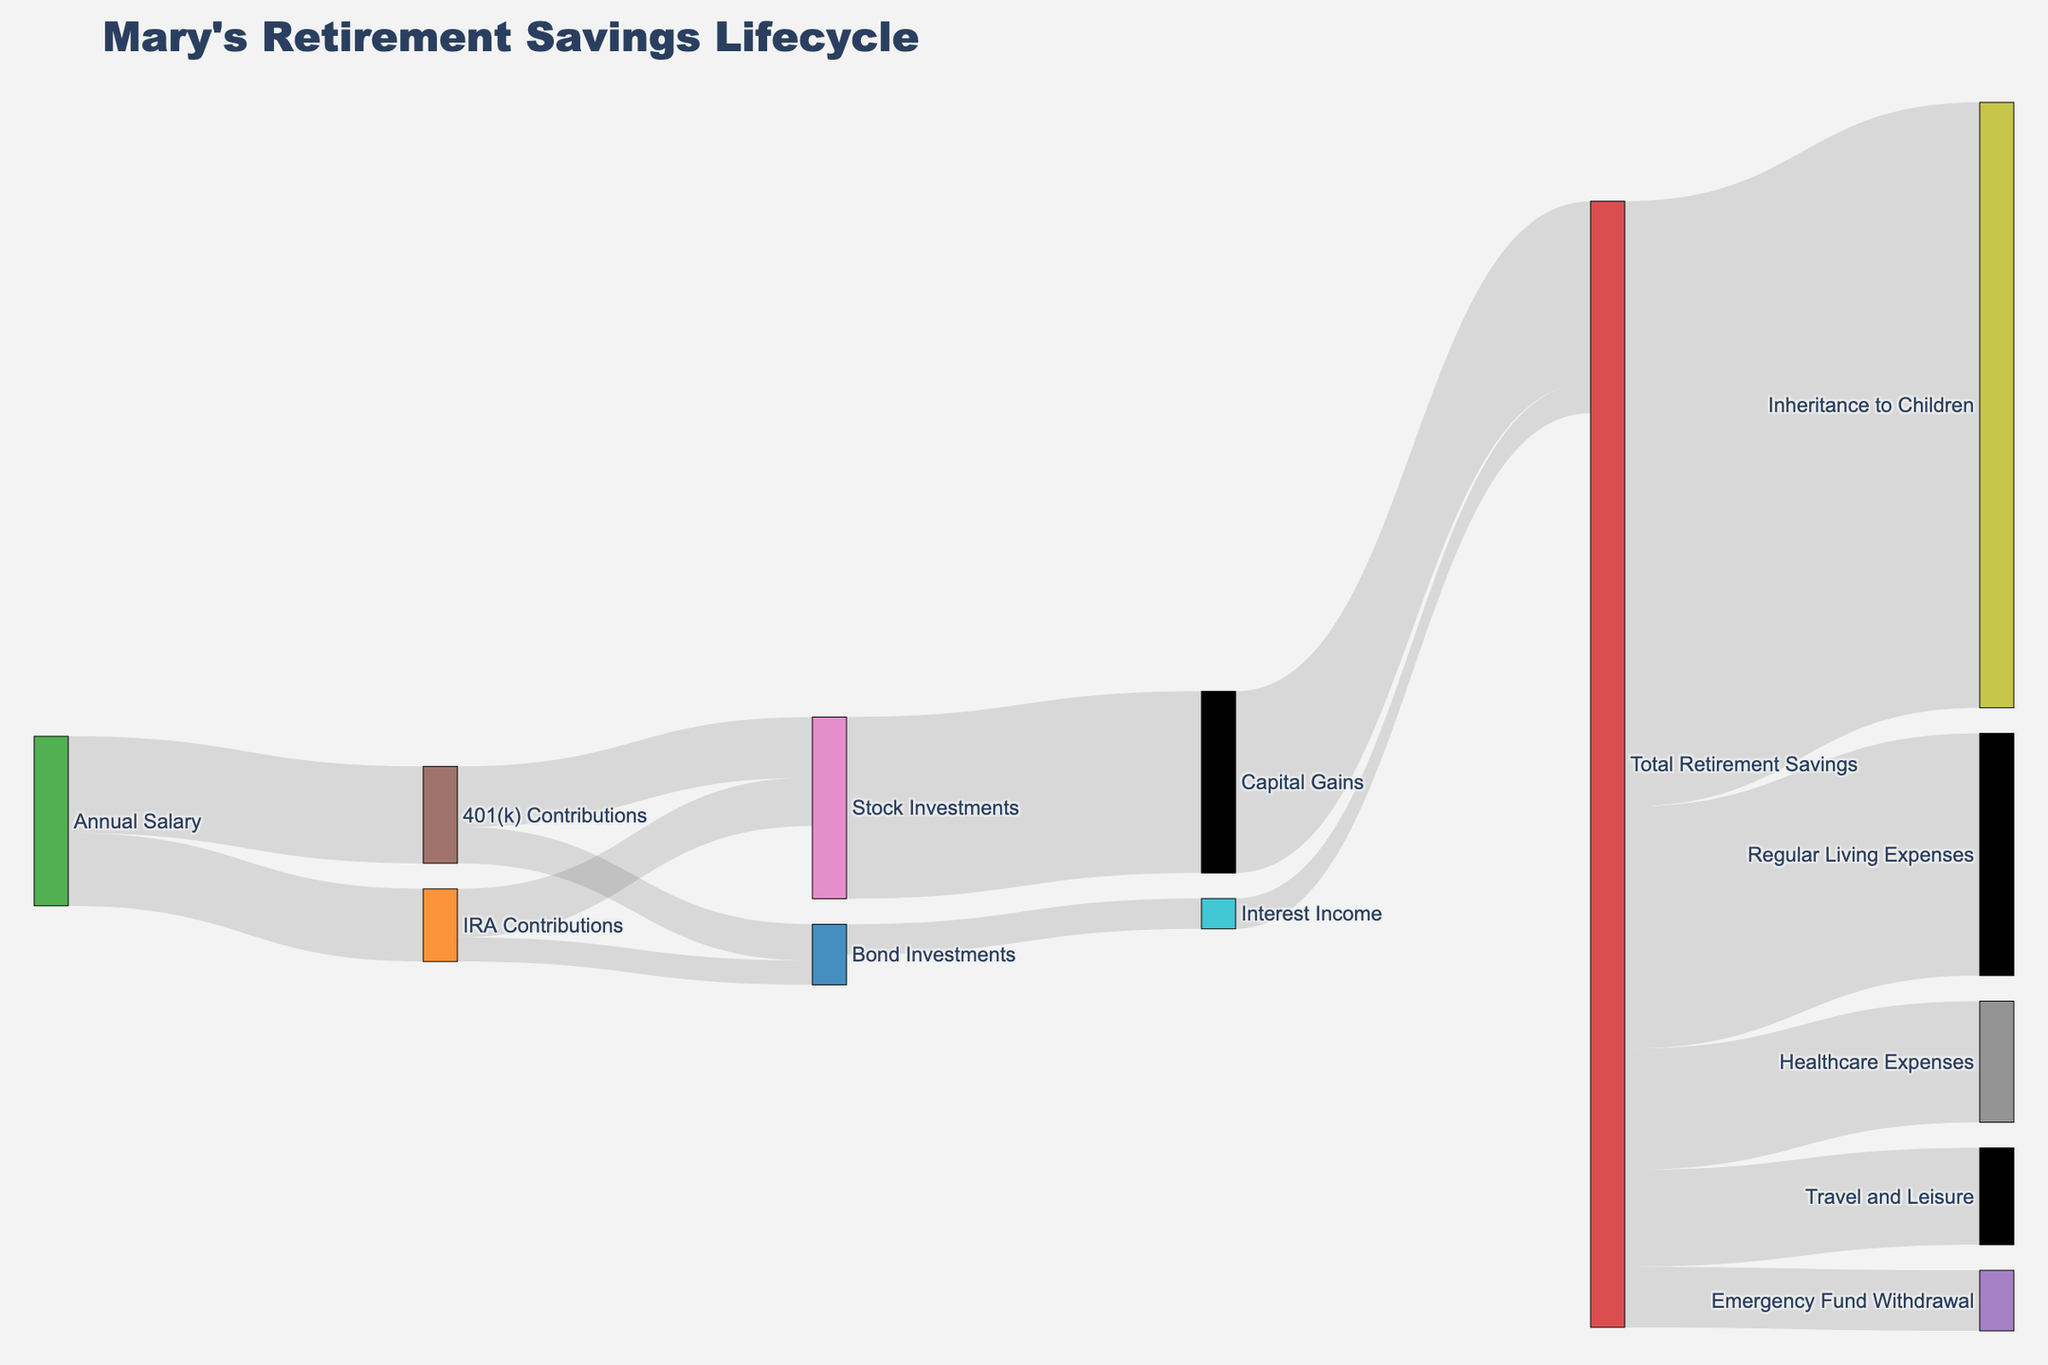What is the largest contribution to Mary's Retirement Savings Lifecycle? The diagram shows contributions from multiple sources. By observing the highest link value contributing to "Total Retirement Savings", we see "Capital Gains" with a value of $15,000.
Answer: Capital Gains How much total did Mary's annual salary contribute to her retirement? Sum the contributions from "Annual Salary" to all its targets, which are $8,000 to 401(k) Contributions and $6,000 to IRA Contributions. Total is $8,000 + $6,000 = $14,000.
Answer: $14,000 What is the total amount withdrawn from Mary's retirement savings? Sum the values of all links that target withdrawals such as "Emergency Fund Withdrawal", "Healthcare Expenses", "Regular Living Expenses", "Travel and Leisure", and "Inheritance to Children". That results in $5,000 + $10,000 + $20,000 + $8,000 + $50,000 = $93,000.
Answer: $93,000 Which has the higher value, Mary's investment in bonds through 401(k) or IRA Contributions? Compare values for "401(k) Contributions" to "Bond Investments" ($3,000) and "IRA Contributions" to "Bond Investments" ($2,000).
Answer: 401(k) Contributions to Bond Investments How much total is invested in stock from both 401(k) and IRA Contributions? Sum the contributions to "Stock Investments" from both "401(k) Contributions" ($5,000) and "IRA Contributions" ($4,000). Total is $5,000 + $4,000 = $9,000.
Answer: $9,000 Which withdrawal category receives more funds, Healthcare Expenses or Travel and Leisure? Compare values: "Healthcare Expenses" receives $10,000 and "Travel and Leisure" gets $8,000.
Answer: Healthcare Expenses How much does bond investment grow in terms of interest income? The link from "Bond Investments" to "Interest Income" shows a value of $2,500.
Answer: $2,500 What is the total value contributed to investments in both stocks and bonds from 401(k) Contributions? Sum investments from "401(k) Contributions" to "Stock Investments" ($5,000) and "Bond Investments" ($3,000). Total is $5,000 + $3,000 = $8,000.
Answer: $8,000 How much of Mary's retirement savings is allocated to Regular Living Expenses compared to Emergency Fund Withdrawal? Compare "Regular Living Expenses" with a value of $20,000 to "Emergency Fund Withdrawal" with $5,000.
Answer: Regular Living Expenses is more 